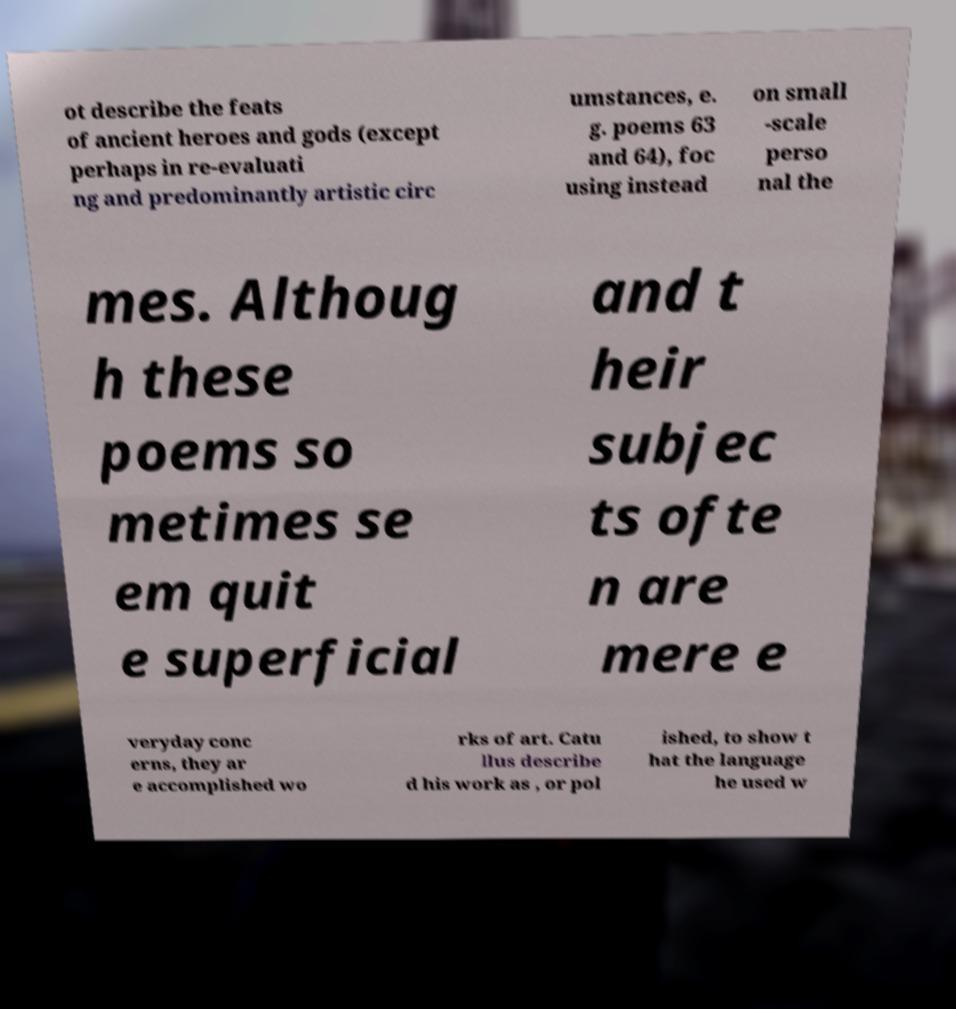Please read and relay the text visible in this image. What does it say? ot describe the feats of ancient heroes and gods (except perhaps in re-evaluati ng and predominantly artistic circ umstances, e. g. poems 63 and 64), foc using instead on small -scale perso nal the mes. Althoug h these poems so metimes se em quit e superficial and t heir subjec ts ofte n are mere e veryday conc erns, they ar e accomplished wo rks of art. Catu llus describe d his work as , or pol ished, to show t hat the language he used w 